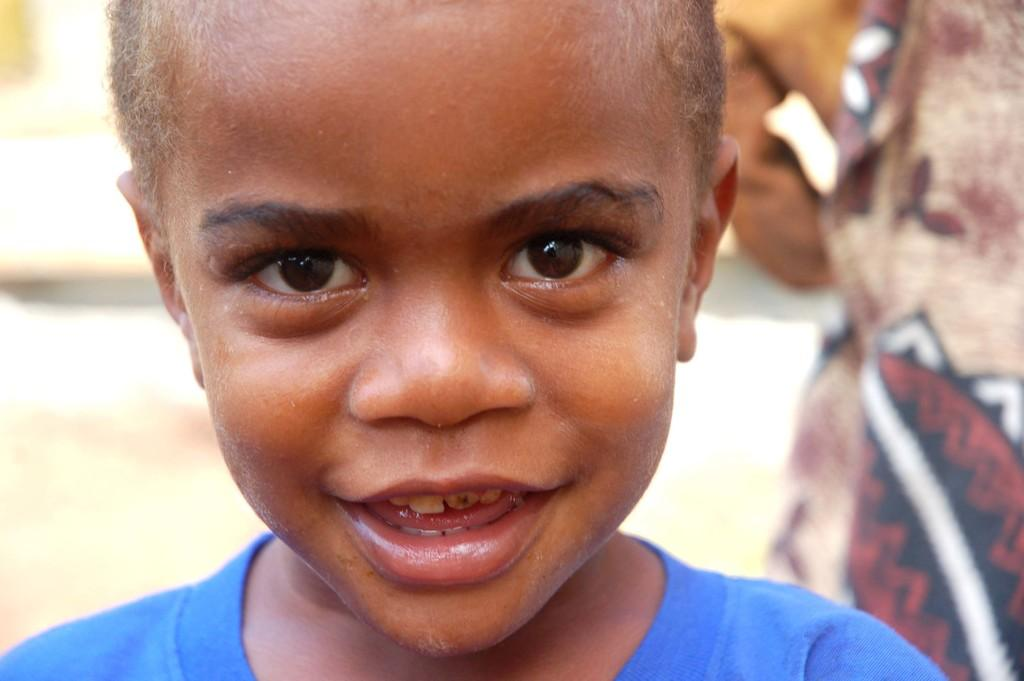What is the main subject of the image? There is a small boy in the image. What is the boy wearing? The boy is wearing a blue t-shirt. Where is the boy positioned in the image? The boy is standing in the front of the image. What is the boy doing in the image? The boy is looking at the camera. How would you describe the background of the image? The background of the image is blurred. What time of day is the boy kicking a soccer ball in the image? There is no soccer ball present in the image, and the time of day cannot be determined from the provided facts. 